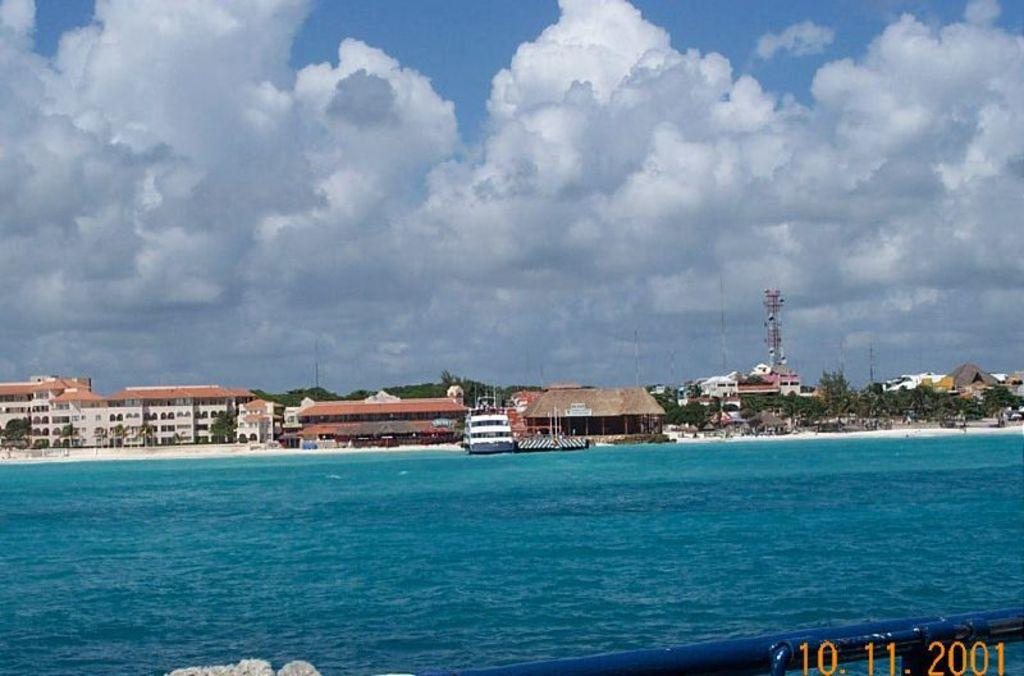What is the primary element visible in the image? There is water in the image. What object can be seen in the water? There is a rod in the water. Where can the date be found in the image? The date is visible in the bottom right of the image. What can be seen in the distance in the image? There are buildings, trees, and the sky visible in the background of the image. What is the condition of the sky in the image? Clouds are present in the sky. What type of wound can be seen on the fish in the image? There is no fish or wound present in the image. What kind of bait is being used to catch the fish in the image? There is no fishing activity or bait present in the image. 